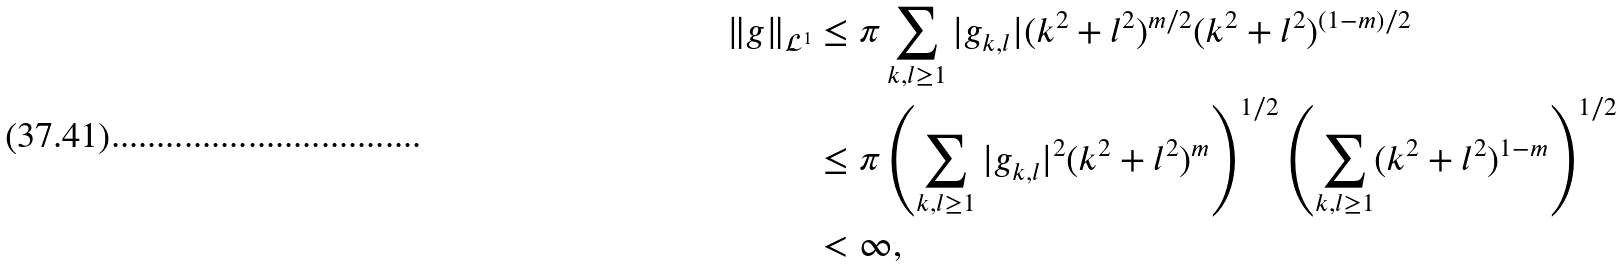Convert formula to latex. <formula><loc_0><loc_0><loc_500><loc_500>\| g \| _ { \mathcal { L } ^ { 1 } } & \leq \pi \sum _ { k , l \geq 1 } | g _ { k , l } | ( k ^ { 2 } + l ^ { 2 } ) ^ { m / 2 } ( k ^ { 2 } + l ^ { 2 } ) ^ { ( 1 - m ) / 2 } \\ & \leq \pi \left ( \sum _ { k , l \geq 1 } | g _ { k , l } | ^ { 2 } ( k ^ { 2 } + l ^ { 2 } ) ^ { m } \right ) ^ { 1 / 2 } \left ( \sum _ { k , l \geq 1 } ( k ^ { 2 } + l ^ { 2 } ) ^ { 1 - m } \right ) ^ { 1 / 2 } \\ & < \infty ,</formula> 